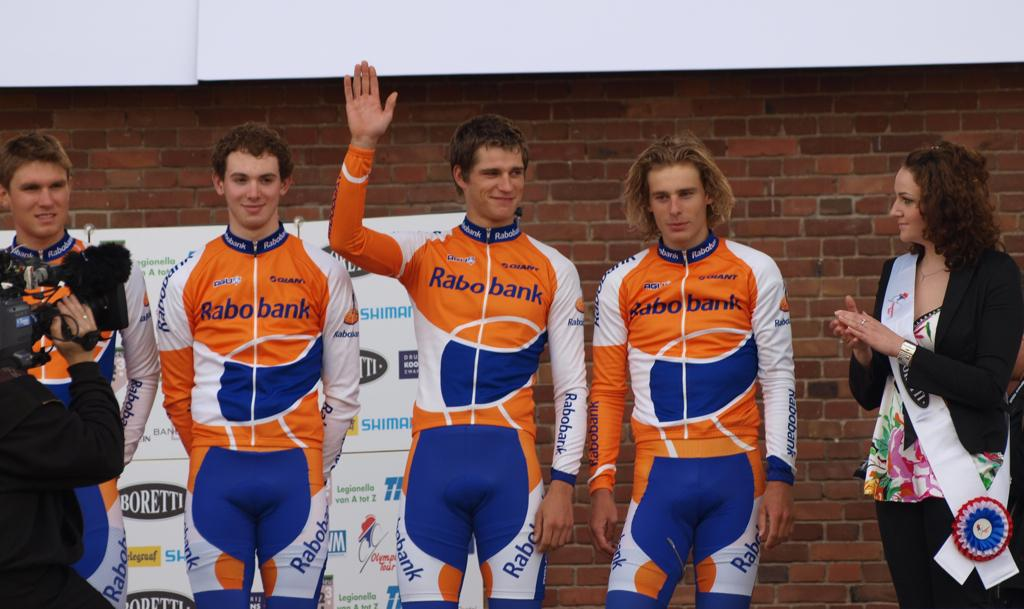<image>
Render a clear and concise summary of the photo. People have orange, blue, and white uniforms with the Rabo bank logo on the front. 